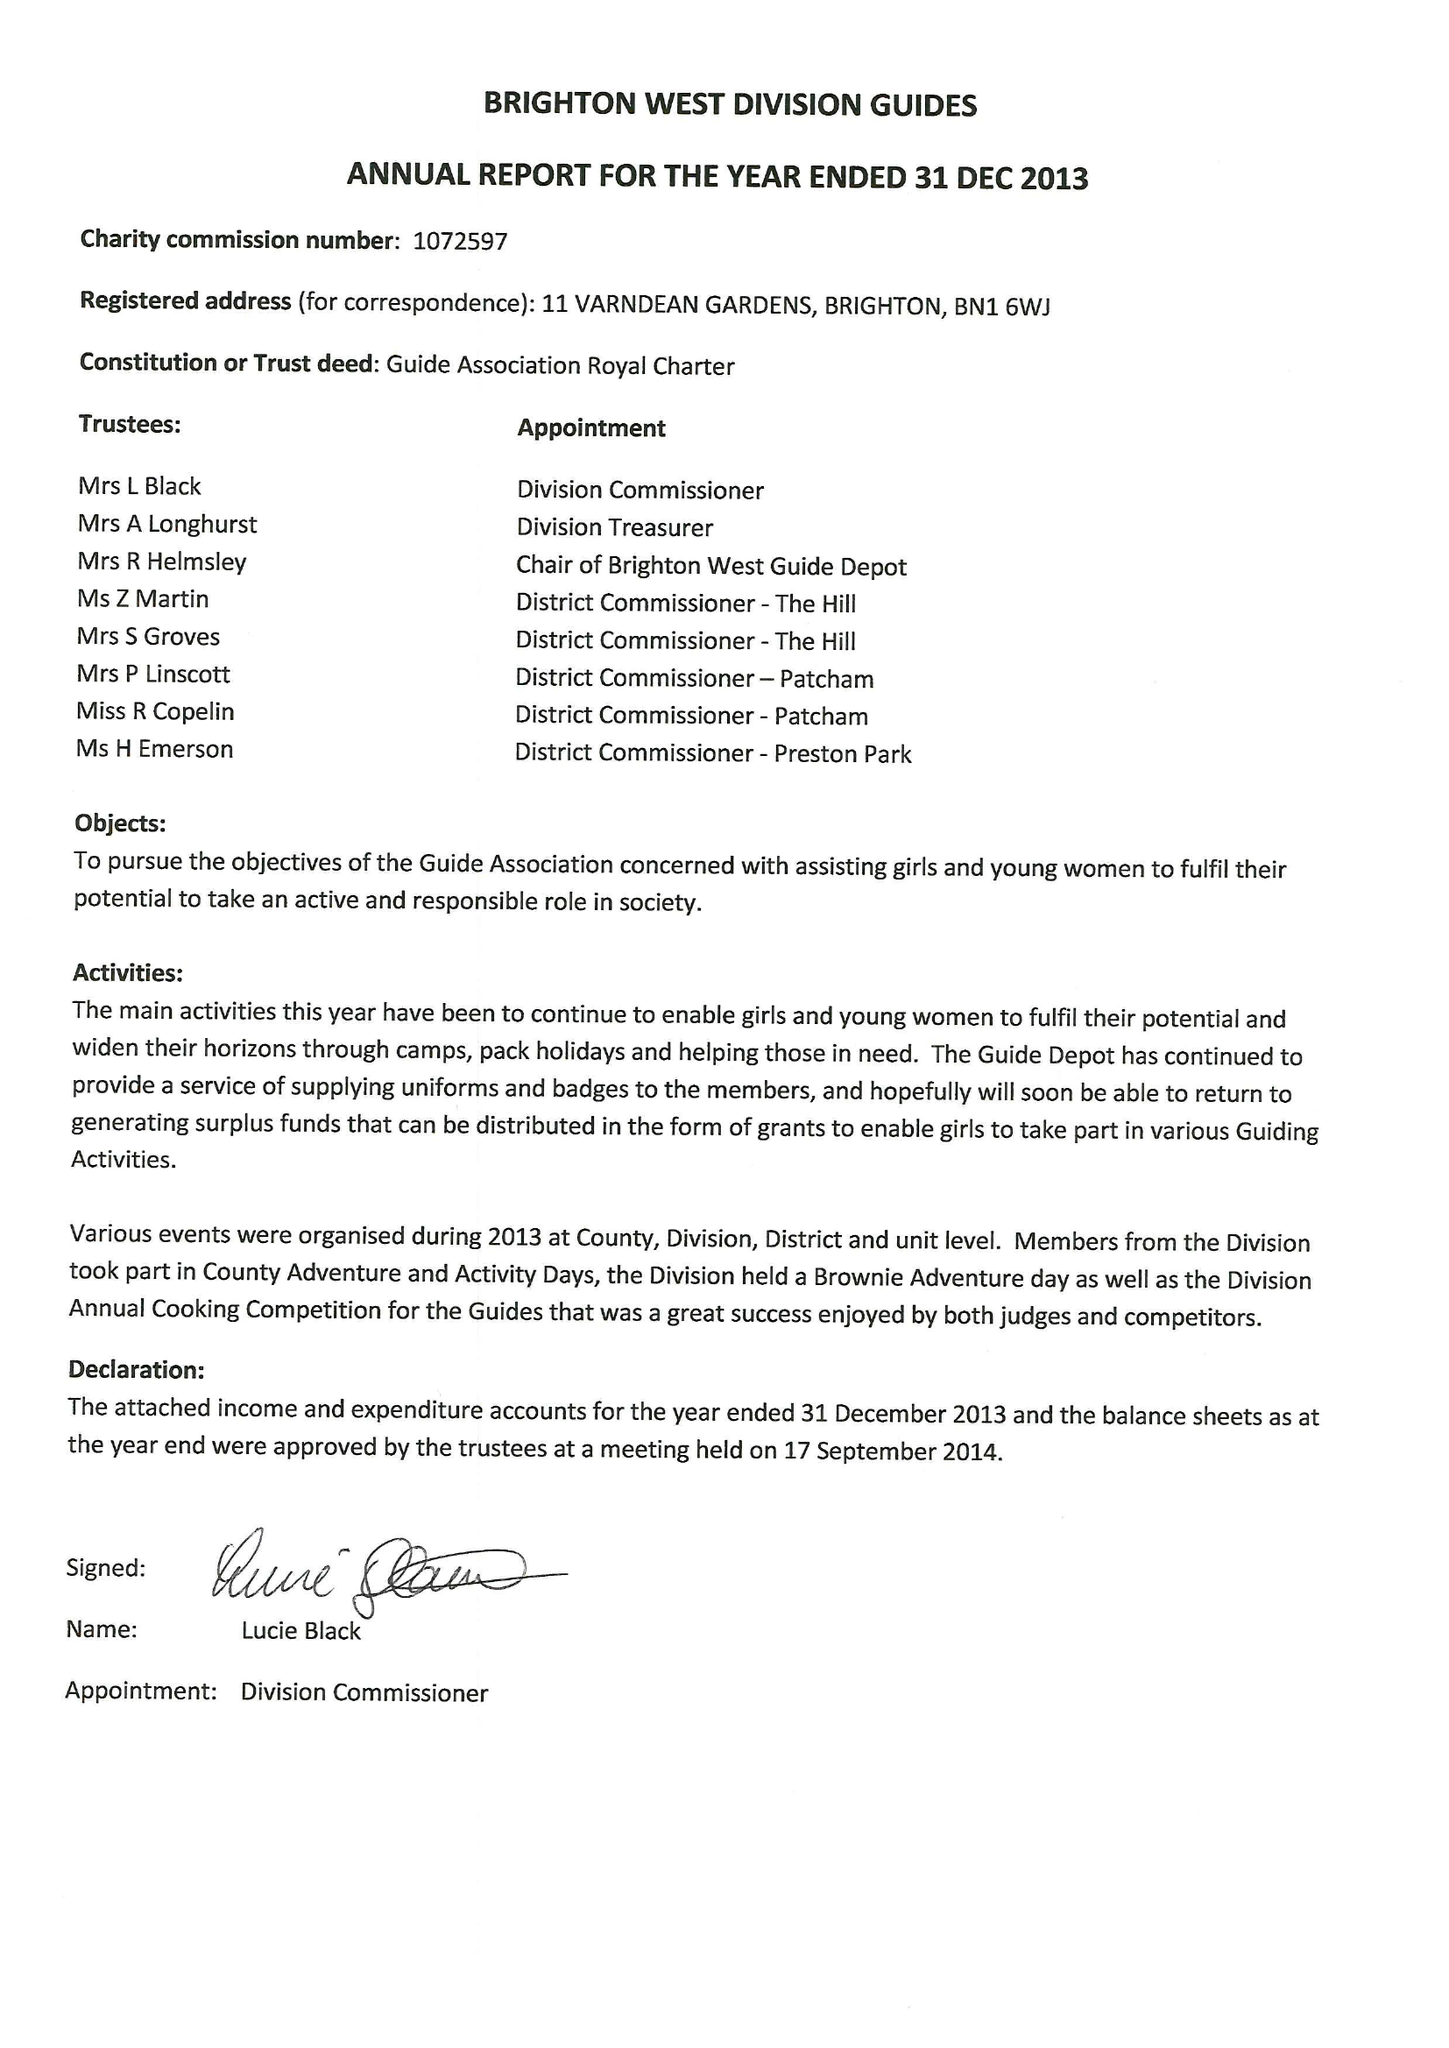What is the value for the address__postcode?
Answer the question using a single word or phrase. BN1 6WJ 